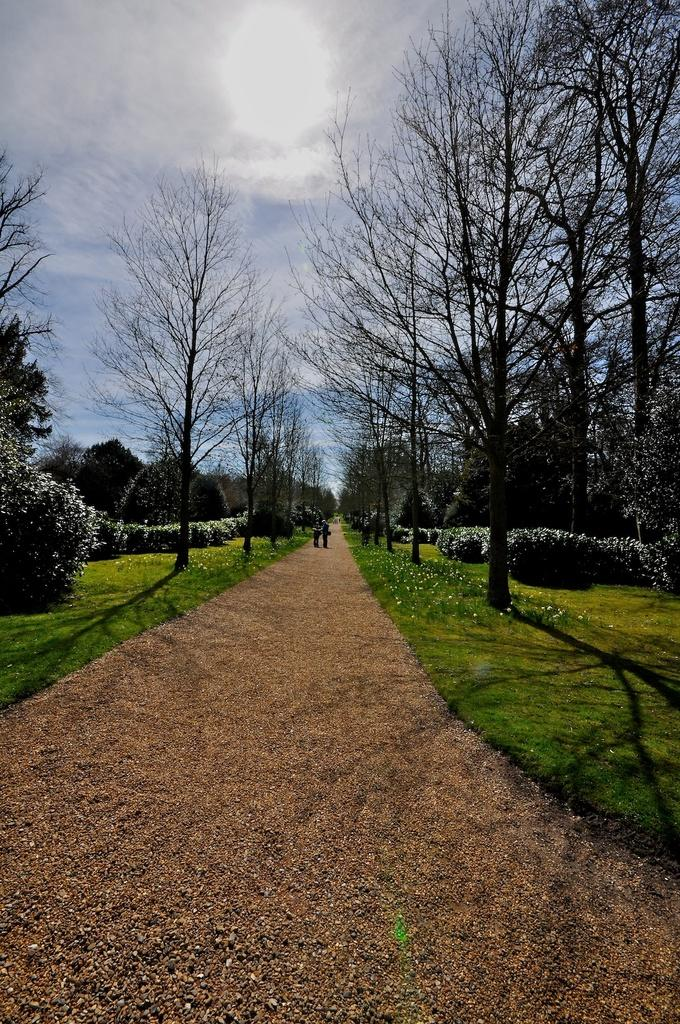What is the main feature in the center of the image? There is a walkway in the center of the image. What type of vegetation can be seen in the image? Trees and bushes are visible in the image. What is visible in the background of the image? The sky is visible in the background of the image. Can you tell me when the birth of the visitor occurred in the image? There is no reference to a birth or visitor in the image, so it is not possible to determine when the birth of a visitor occurred. 